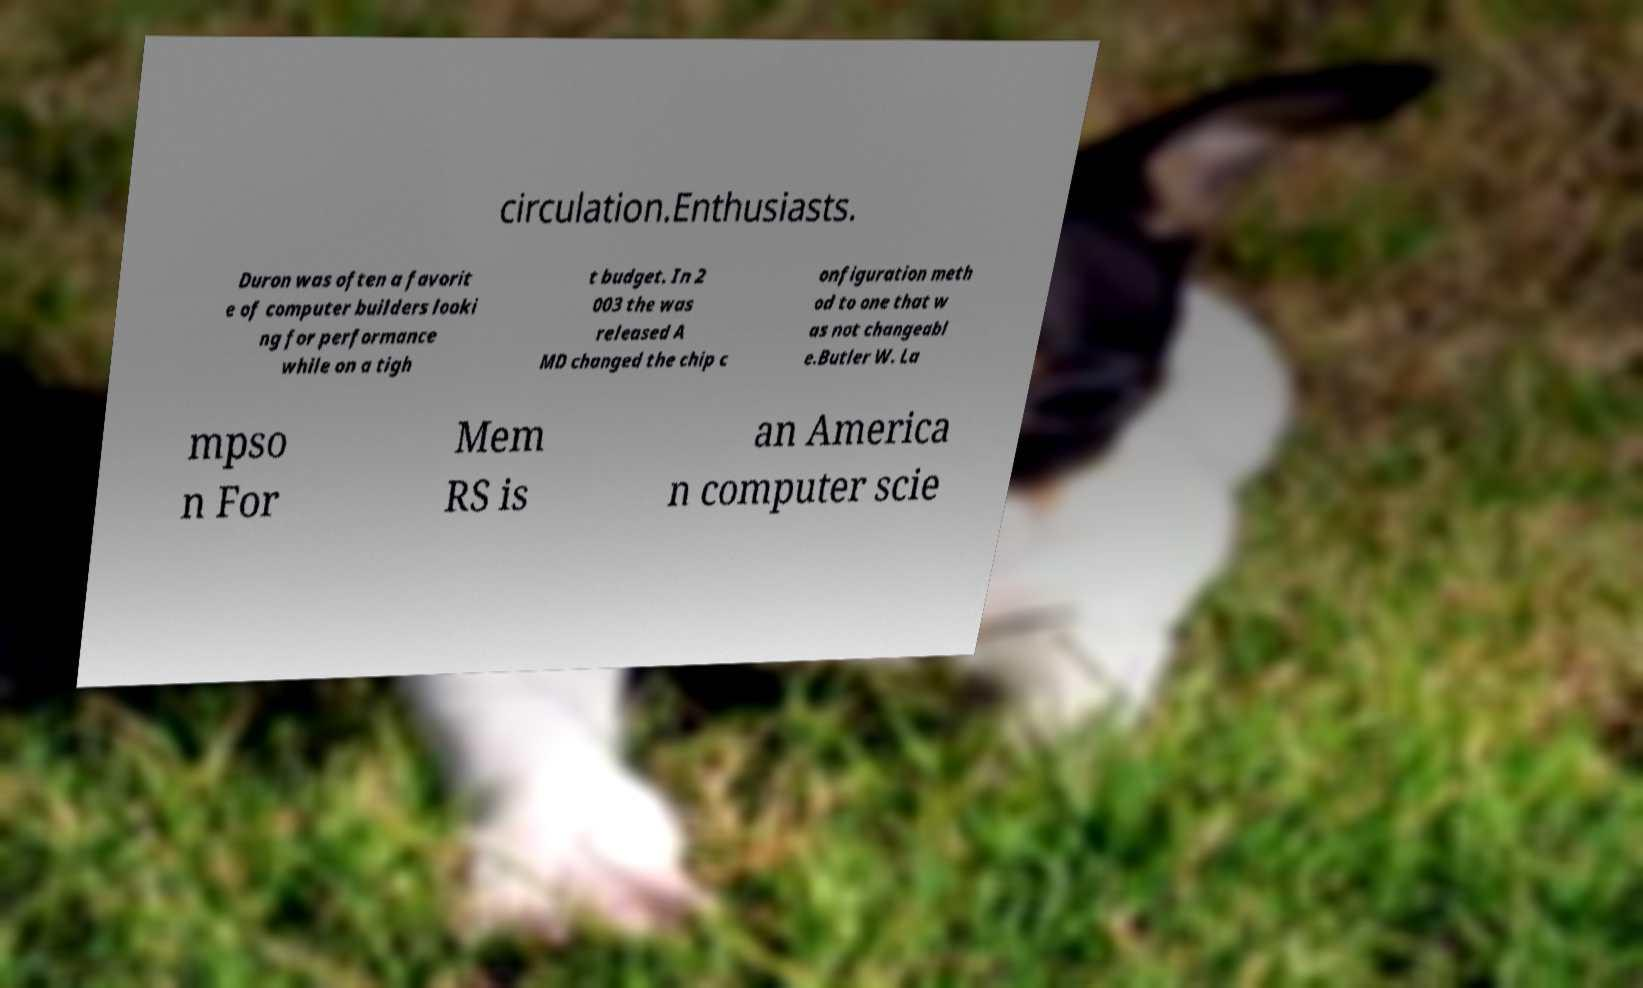Can you accurately transcribe the text from the provided image for me? circulation.Enthusiasts. Duron was often a favorit e of computer builders looki ng for performance while on a tigh t budget. In 2 003 the was released A MD changed the chip c onfiguration meth od to one that w as not changeabl e.Butler W. La mpso n For Mem RS is an America n computer scie 